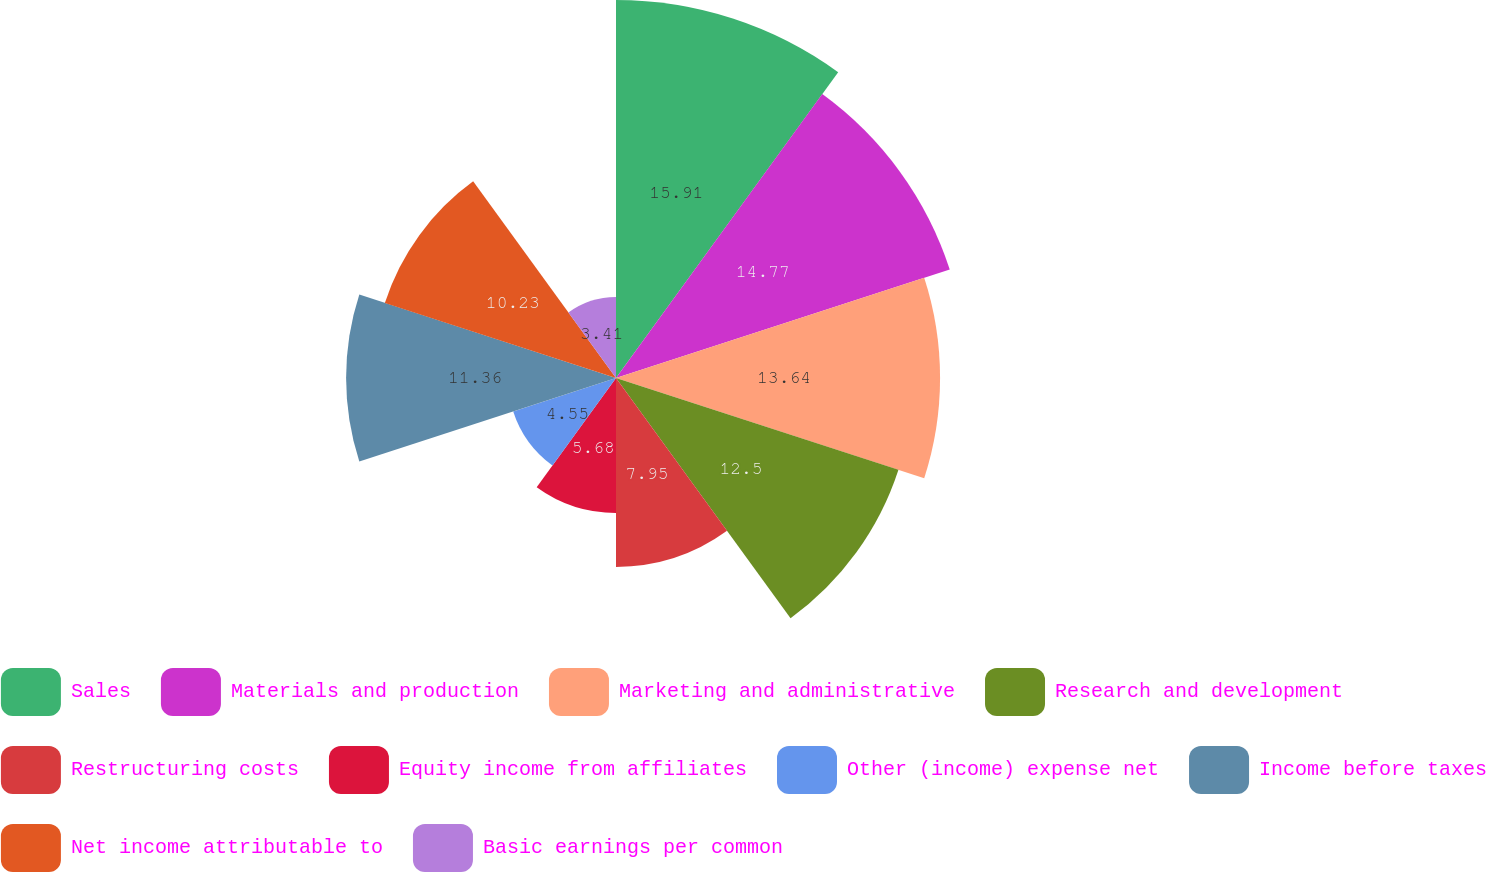Convert chart. <chart><loc_0><loc_0><loc_500><loc_500><pie_chart><fcel>Sales<fcel>Materials and production<fcel>Marketing and administrative<fcel>Research and development<fcel>Restructuring costs<fcel>Equity income from affiliates<fcel>Other (income) expense net<fcel>Income before taxes<fcel>Net income attributable to<fcel>Basic earnings per common<nl><fcel>15.91%<fcel>14.77%<fcel>13.64%<fcel>12.5%<fcel>7.95%<fcel>5.68%<fcel>4.55%<fcel>11.36%<fcel>10.23%<fcel>3.41%<nl></chart> 